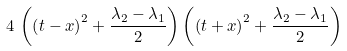<formula> <loc_0><loc_0><loc_500><loc_500>4 \, \left ( \left ( t - x \right ) ^ { 2 } + \frac { \lambda _ { 2 } - \lambda _ { 1 } } { 2 } \right ) \left ( \left ( t + x \right ) ^ { 2 } + \frac { \lambda _ { 2 } - \lambda _ { 1 } } { 2 } \right )</formula> 